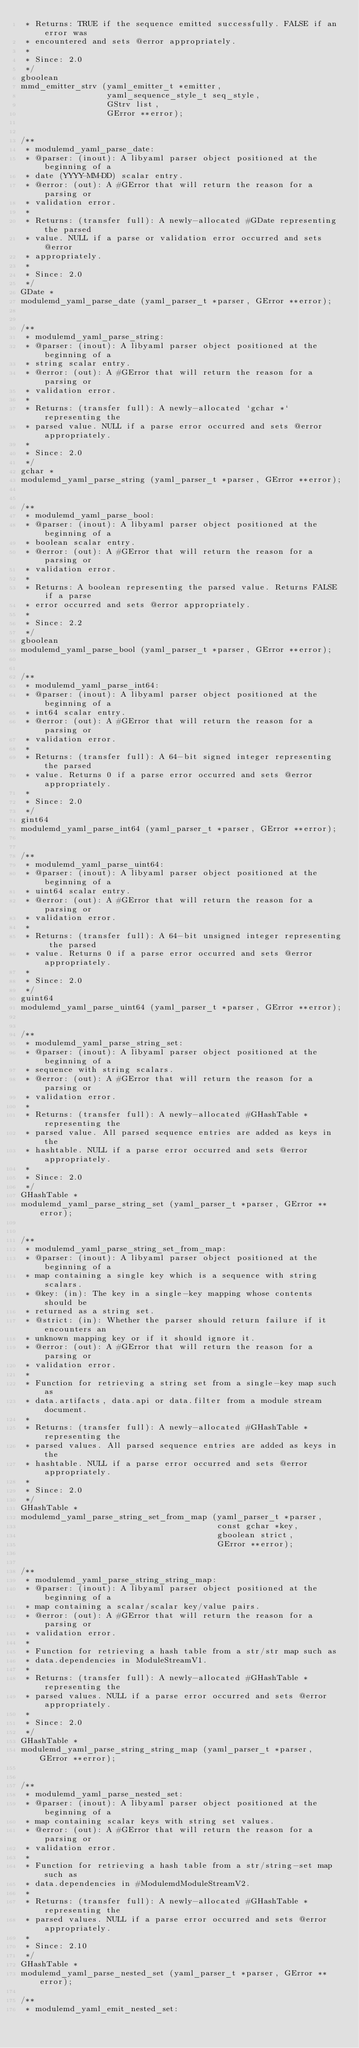<code> <loc_0><loc_0><loc_500><loc_500><_C_> * Returns: TRUE if the sequence emitted successfully. FALSE if an error was
 * encountered and sets @error appropriately.
 *
 * Since: 2.0
 */
gboolean
mmd_emitter_strv (yaml_emitter_t *emitter,
                  yaml_sequence_style_t seq_style,
                  GStrv list,
                  GError **error);


/**
 * modulemd_yaml_parse_date:
 * @parser: (inout): A libyaml parser object positioned at the beginning of a
 * date (YYYY-MM-DD) scalar entry.
 * @error: (out): A #GError that will return the reason for a parsing or
 * validation error.
 *
 * Returns: (transfer full): A newly-allocated #GDate representing the parsed
 * value. NULL if a parse or validation error occurred and sets @error
 * appropriately.
 *
 * Since: 2.0
 */
GDate *
modulemd_yaml_parse_date (yaml_parser_t *parser, GError **error);


/**
 * modulemd_yaml_parse_string:
 * @parser: (inout): A libyaml parser object positioned at the beginning of a
 * string scalar entry.
 * @error: (out): A #GError that will return the reason for a parsing or
 * validation error.
 *
 * Returns: (transfer full): A newly-allocated `gchar *` representing the
 * parsed value. NULL if a parse error occurred and sets @error appropriately.
 *
 * Since: 2.0
 */
gchar *
modulemd_yaml_parse_string (yaml_parser_t *parser, GError **error);


/**
 * modulemd_yaml_parse_bool:
 * @parser: (inout): A libyaml parser object positioned at the beginning of a
 * boolean scalar entry.
 * @error: (out): A #GError that will return the reason for a parsing or
 * validation error.
 *
 * Returns: A boolean representing the parsed value. Returns FALSE if a parse
 * error occurred and sets @error appropriately.
 *
 * Since: 2.2
 */
gboolean
modulemd_yaml_parse_bool (yaml_parser_t *parser, GError **error);


/**
 * modulemd_yaml_parse_int64:
 * @parser: (inout): A libyaml parser object positioned at the beginning of a
 * int64 scalar entry.
 * @error: (out): A #GError that will return the reason for a parsing or
 * validation error.
 *
 * Returns: (transfer full): A 64-bit signed integer representing the parsed
 * value. Returns 0 if a parse error occurred and sets @error appropriately.
 *
 * Since: 2.0
 */
gint64
modulemd_yaml_parse_int64 (yaml_parser_t *parser, GError **error);


/**
 * modulemd_yaml_parse_uint64:
 * @parser: (inout): A libyaml parser object positioned at the beginning of a
 * uint64 scalar entry.
 * @error: (out): A #GError that will return the reason for a parsing or
 * validation error.
 *
 * Returns: (transfer full): A 64-bit unsigned integer representing the parsed
 * value. Returns 0 if a parse error occurred and sets @error appropriately.
 *
 * Since: 2.0
 */
guint64
modulemd_yaml_parse_uint64 (yaml_parser_t *parser, GError **error);


/**
 * modulemd_yaml_parse_string_set:
 * @parser: (inout): A libyaml parser object positioned at the beginning of a
 * sequence with string scalars.
 * @error: (out): A #GError that will return the reason for a parsing or
 * validation error.
 *
 * Returns: (transfer full): A newly-allocated #GHashTable * representing the
 * parsed value. All parsed sequence entries are added as keys in the
 * hashtable. NULL if a parse error occurred and sets @error appropriately.
 *
 * Since: 2.0
 */
GHashTable *
modulemd_yaml_parse_string_set (yaml_parser_t *parser, GError **error);


/**
 * modulemd_yaml_parse_string_set_from_map:
 * @parser: (inout): A libyaml parser object positioned at the beginning of a
 * map containing a single key which is a sequence with string scalars.
 * @key: (in): The key in a single-key mapping whose contents should be
 * returned as a string set.
 * @strict: (in): Whether the parser should return failure if it encounters an
 * unknown mapping key or if it should ignore it.
 * @error: (out): A #GError that will return the reason for a parsing or
 * validation error.
 *
 * Function for retrieving a string set from a single-key map such as
 * data.artifacts, data.api or data.filter from a module stream document.
 *
 * Returns: (transfer full): A newly-allocated #GHashTable * representing the
 * parsed values. All parsed sequence entries are added as keys in the
 * hashtable. NULL if a parse error occurred and sets @error appropriately.
 *
 * Since: 2.0
 */
GHashTable *
modulemd_yaml_parse_string_set_from_map (yaml_parser_t *parser,
                                         const gchar *key,
                                         gboolean strict,
                                         GError **error);


/**
 * modulemd_yaml_parse_string_string_map:
 * @parser: (inout): A libyaml parser object positioned at the beginning of a
 * map containing a scalar/scalar key/value pairs.
 * @error: (out): A #GError that will return the reason for a parsing or
 * validation error.
 *
 * Function for retrieving a hash table from a str/str map such as
 * data.dependencies in ModuleStreamV1.
 *
 * Returns: (transfer full): A newly-allocated #GHashTable * representing the
 * parsed values. NULL if a parse error occurred and sets @error appropriately.
 *
 * Since: 2.0
 */
GHashTable *
modulemd_yaml_parse_string_string_map (yaml_parser_t *parser, GError **error);


/**
 * modulemd_yaml_parse_nested_set:
 * @parser: (inout): A libyaml parser object positioned at the beginning of a
 * map containing scalar keys with string set values.
 * @error: (out): A #GError that will return the reason for a parsing or
 * validation error.
 *
 * Function for retrieving a hash table from a str/string-set map such as
 * data.dependencies in #ModulemdModuleStreamV2.
 *
 * Returns: (transfer full): A newly-allocated #GHashTable * representing the
 * parsed values. NULL if a parse error occurred and sets @error appropriately.
 *
 * Since: 2.10
 */
GHashTable *
modulemd_yaml_parse_nested_set (yaml_parser_t *parser, GError **error);

/**
 * modulemd_yaml_emit_nested_set:</code> 